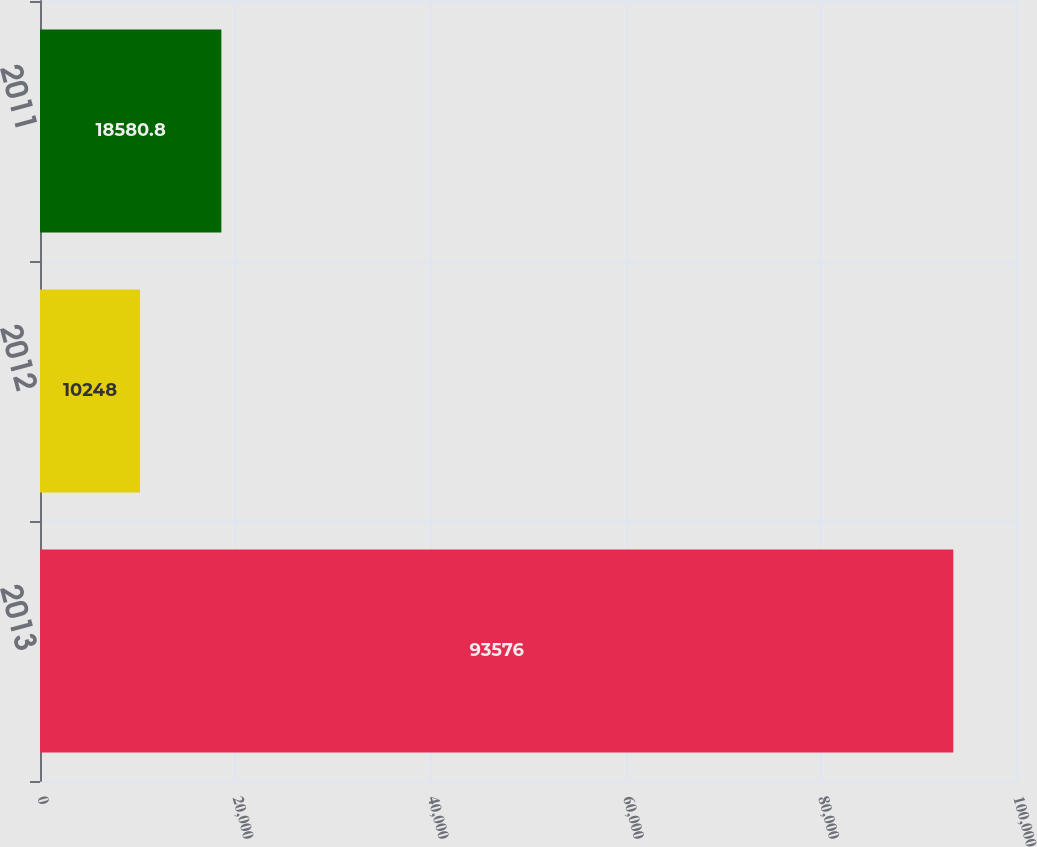Convert chart to OTSL. <chart><loc_0><loc_0><loc_500><loc_500><bar_chart><fcel>2013<fcel>2012<fcel>2011<nl><fcel>93576<fcel>10248<fcel>18580.8<nl></chart> 